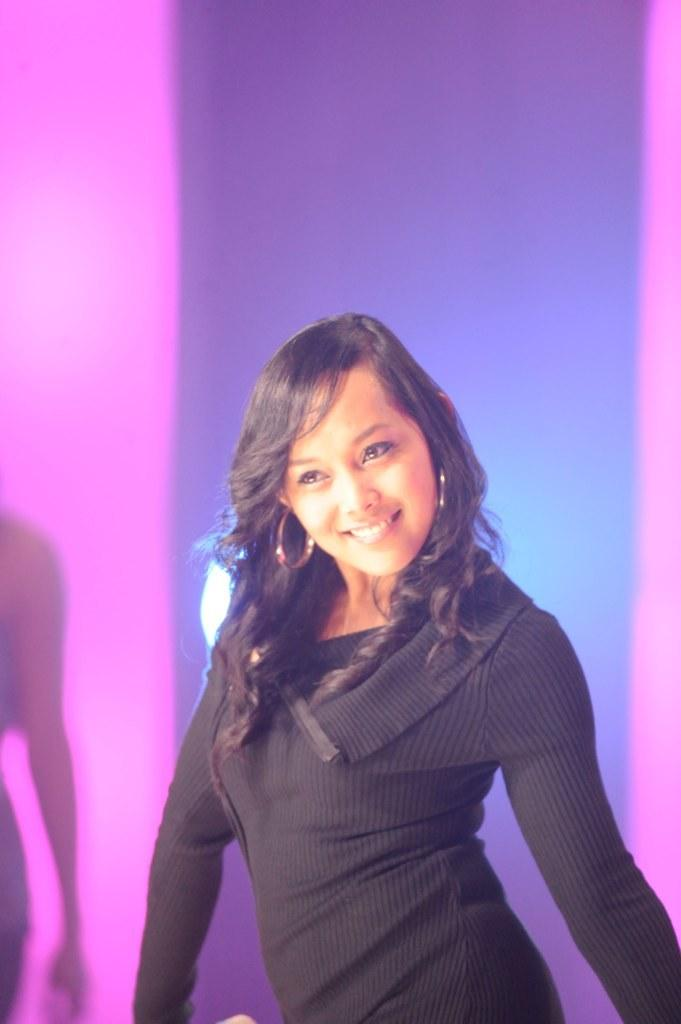What is the main subject of the image? The main subject of the image is a woman. What is the woman wearing in the image? The woman is wearing a black dress in the image. What expression does the woman have in the image? The woman is smiling in the image. How many deer can be seen in the image? There are no deer present in the image; it features a woman wearing a black dress and smiling. 